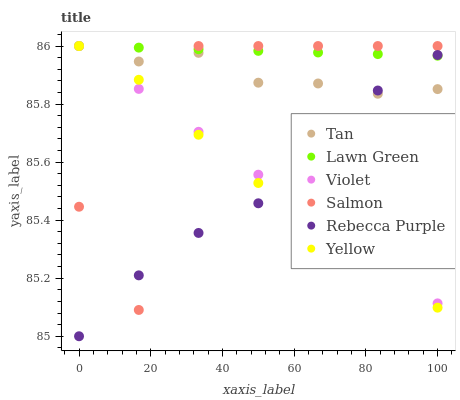Does Rebecca Purple have the minimum area under the curve?
Answer yes or no. Yes. Does Lawn Green have the maximum area under the curve?
Answer yes or no. Yes. Does Salmon have the minimum area under the curve?
Answer yes or no. No. Does Salmon have the maximum area under the curve?
Answer yes or no. No. Is Violet the smoothest?
Answer yes or no. Yes. Is Salmon the roughest?
Answer yes or no. Yes. Is Yellow the smoothest?
Answer yes or no. No. Is Yellow the roughest?
Answer yes or no. No. Does Rebecca Purple have the lowest value?
Answer yes or no. Yes. Does Salmon have the lowest value?
Answer yes or no. No. Does Tan have the highest value?
Answer yes or no. Yes. Does Rebecca Purple have the highest value?
Answer yes or no. No. Does Rebecca Purple intersect Salmon?
Answer yes or no. Yes. Is Rebecca Purple less than Salmon?
Answer yes or no. No. Is Rebecca Purple greater than Salmon?
Answer yes or no. No. 